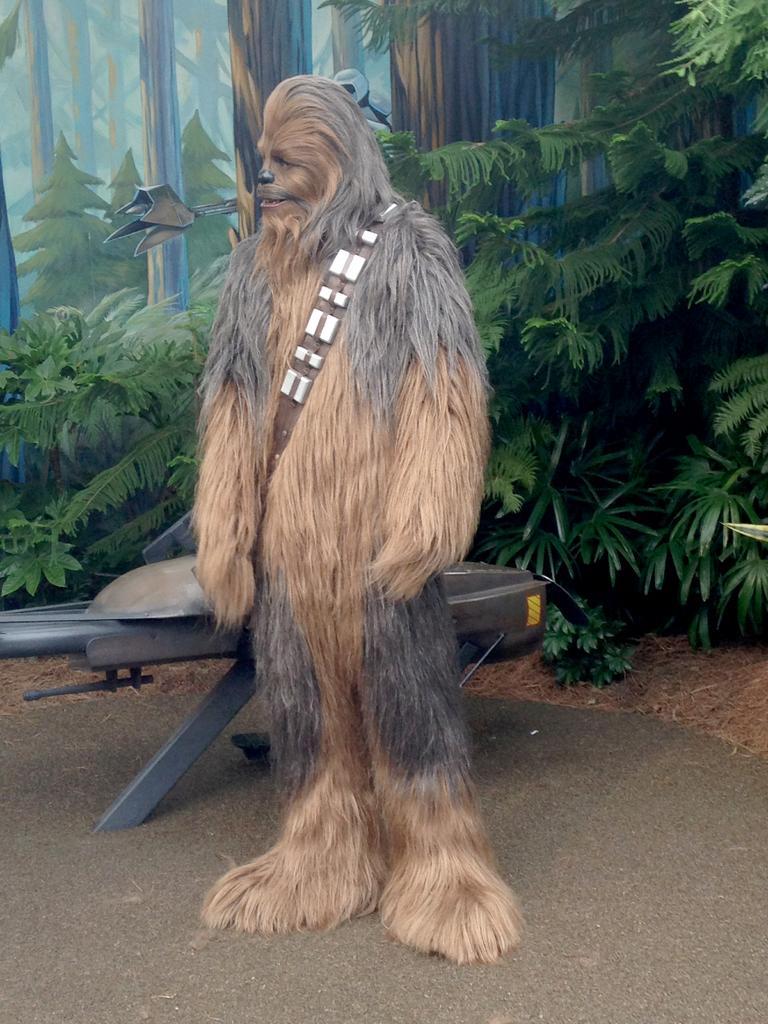Could you give a brief overview of what you see in this image? In the center of the image, we can see a person wearing costume and in the background, there is a stand and we can see trees and plants and there is a painting on the wall. At the bottom, there is road. 